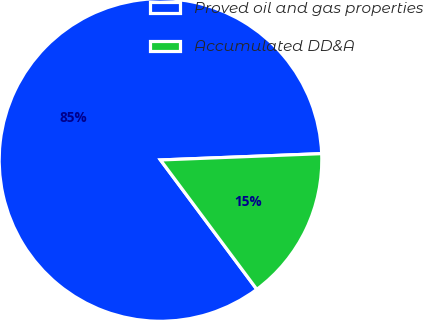Convert chart to OTSL. <chart><loc_0><loc_0><loc_500><loc_500><pie_chart><fcel>Proved oil and gas properties<fcel>Accumulated DD&A<nl><fcel>84.56%<fcel>15.44%<nl></chart> 